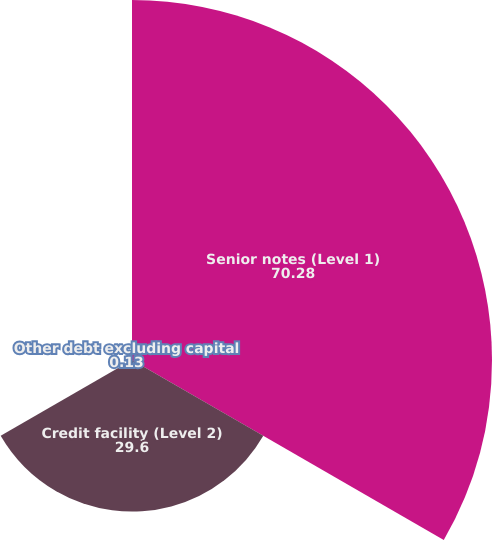Convert chart. <chart><loc_0><loc_0><loc_500><loc_500><pie_chart><fcel>Senior notes (Level 1)<fcel>Credit facility (Level 2)<fcel>Other debt excluding capital<nl><fcel>70.28%<fcel>29.6%<fcel>0.13%<nl></chart> 